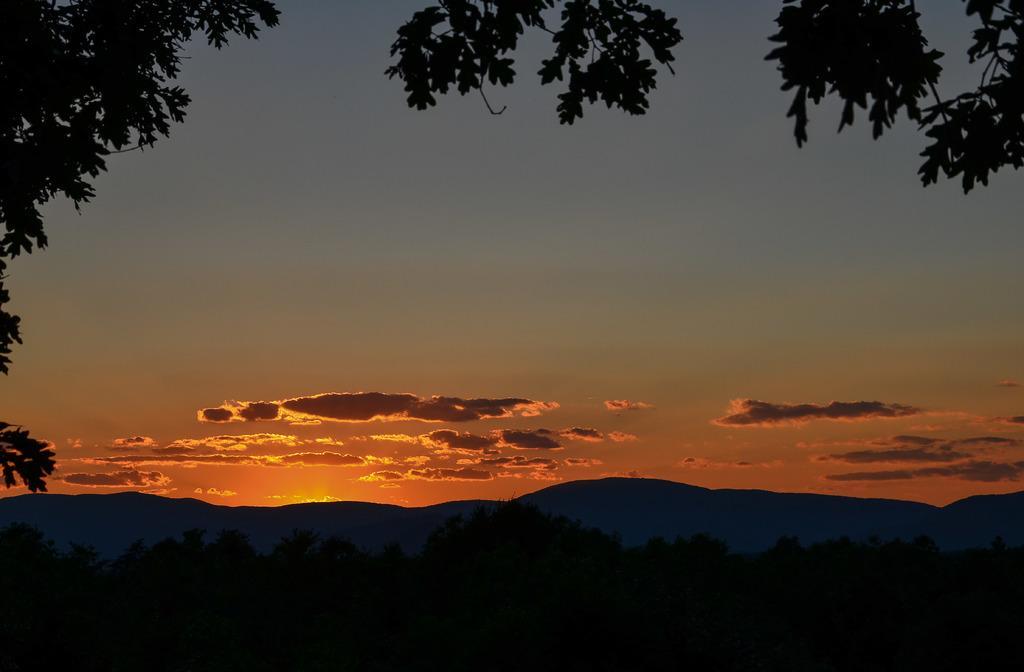Please provide a concise description of this image. In this picture we can see few trees, hills and clouds. 